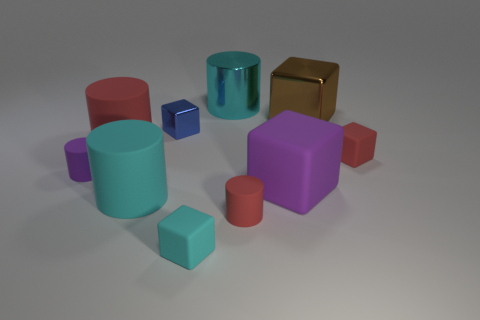Are there any large cyan matte things of the same shape as the blue metal object?
Give a very brief answer. No. There is a tiny blue shiny cube to the right of the big red matte cylinder; are there any cylinders to the left of it?
Offer a very short reply. Yes. How many things are either cylinders on the left side of the tiny metal cube or red cylinders that are in front of the purple rubber cube?
Give a very brief answer. 4. What number of objects are purple matte cylinders or cubes in front of the purple matte cylinder?
Provide a short and direct response. 3. What size is the red cube in front of the large block behind the red matte thing left of the big cyan metallic thing?
Give a very brief answer. Small. There is a red block that is the same size as the purple rubber cylinder; what is its material?
Offer a terse response. Rubber. Is there a cyan rubber object that has the same size as the brown cube?
Keep it short and to the point. Yes. There is a cyan cylinder behind the purple matte cylinder; is it the same size as the tiny cyan object?
Give a very brief answer. No. The big object that is in front of the small metallic thing and behind the small purple rubber object has what shape?
Your answer should be very brief. Cylinder. Are there more big cyan things behind the large cyan rubber object than small yellow blocks?
Provide a short and direct response. Yes. 